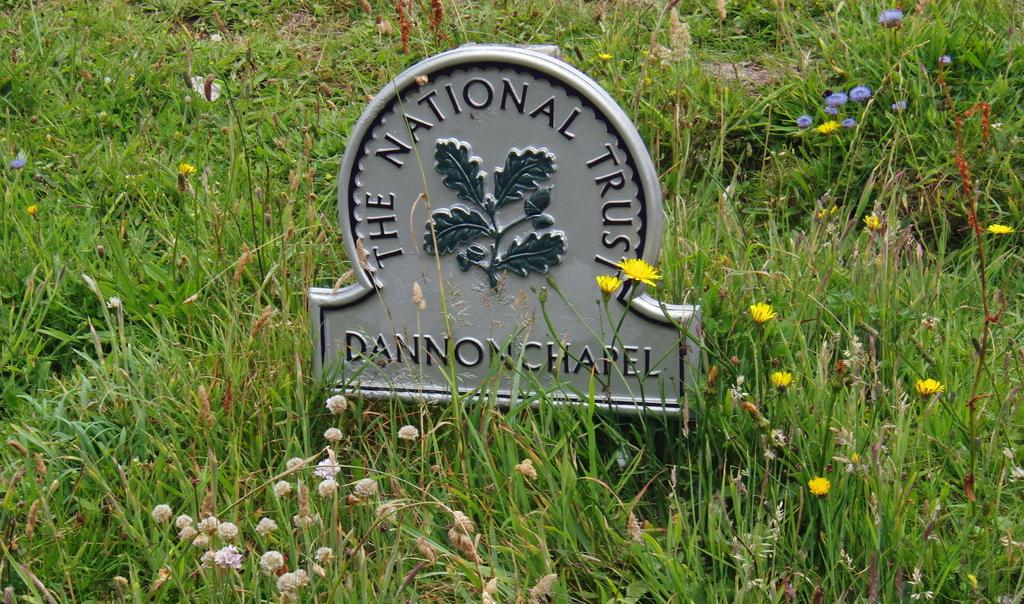What type of object is visible in the image that resembles a headstone? There is an object in the image that appears to be a headstone. What can be found on the headstone? There is text on the headstone. What is covering the headstone? There are leaves on the headstone. What type of vegetation surrounds the headstone? There is grass surrounding the headstone, and there are plants in the vicinity of the headstone. What type of decoration is present in the image? There are flowers present. What type of fan can be seen in the image? There is no fan present in the image. Is there a sidewalk visible in the image? There is no sidewalk visible in the image. What type of books can be found in the library depicted in the image? There is no library present in the image. 